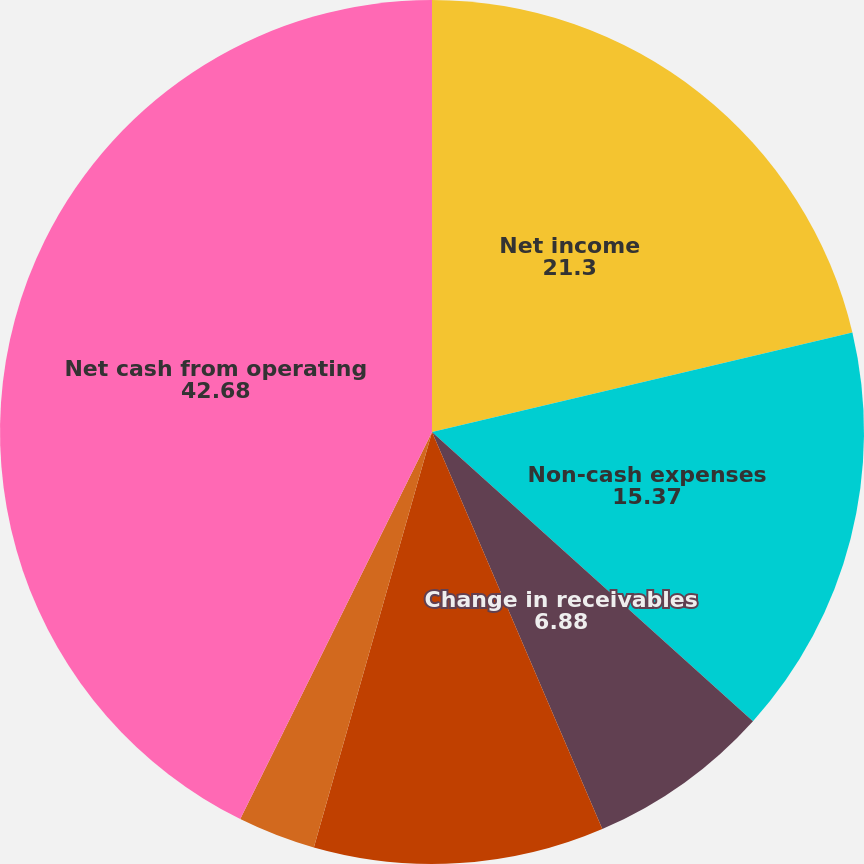Convert chart. <chart><loc_0><loc_0><loc_500><loc_500><pie_chart><fcel>Net income<fcel>Non-cash expenses<fcel>Change in receivables<fcel>Change in deferred revenue<fcel>Change in other assets and<fcel>Net cash from operating<nl><fcel>21.3%<fcel>15.37%<fcel>6.88%<fcel>10.86%<fcel>2.91%<fcel>42.68%<nl></chart> 